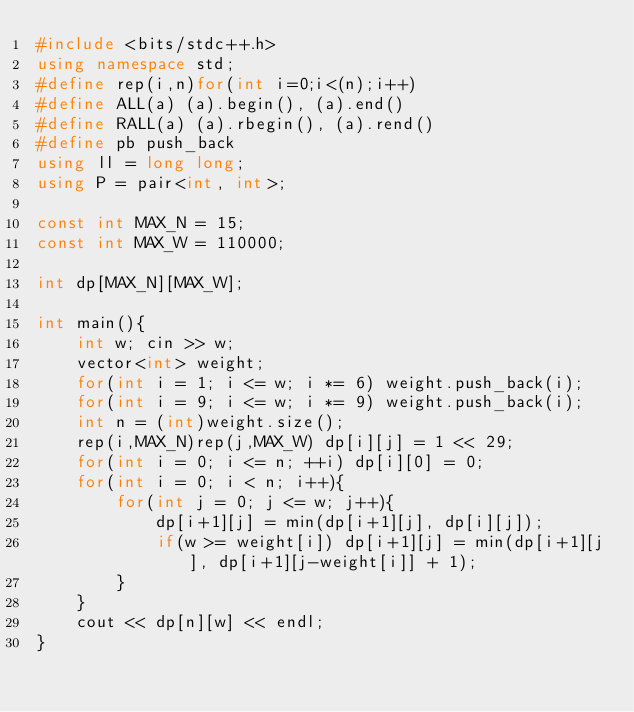Convert code to text. <code><loc_0><loc_0><loc_500><loc_500><_C++_>#include <bits/stdc++.h>
using namespace std;
#define rep(i,n)for(int i=0;i<(n);i++)
#define ALL(a) (a).begin(), (a).end()
#define RALL(a) (a).rbegin(), (a).rend()
#define pb push_back
using ll = long long;
using P = pair<int, int>;

const int MAX_N = 15;
const int MAX_W = 110000;

int dp[MAX_N][MAX_W];

int main(){
    int w; cin >> w;
    vector<int> weight;
    for(int i = 1; i <= w; i *= 6) weight.push_back(i);
    for(int i = 9; i <= w; i *= 9) weight.push_back(i);
    int n = (int)weight.size();
    rep(i,MAX_N)rep(j,MAX_W) dp[i][j] = 1 << 29;
    for(int i = 0; i <= n; ++i) dp[i][0] = 0;
    for(int i = 0; i < n; i++){
        for(int j = 0; j <= w; j++){
            dp[i+1][j] = min(dp[i+1][j], dp[i][j]);
            if(w >= weight[i]) dp[i+1][j] = min(dp[i+1][j], dp[i+1][j-weight[i]] + 1);
        }
    }
    cout << dp[n][w] << endl;
}</code> 